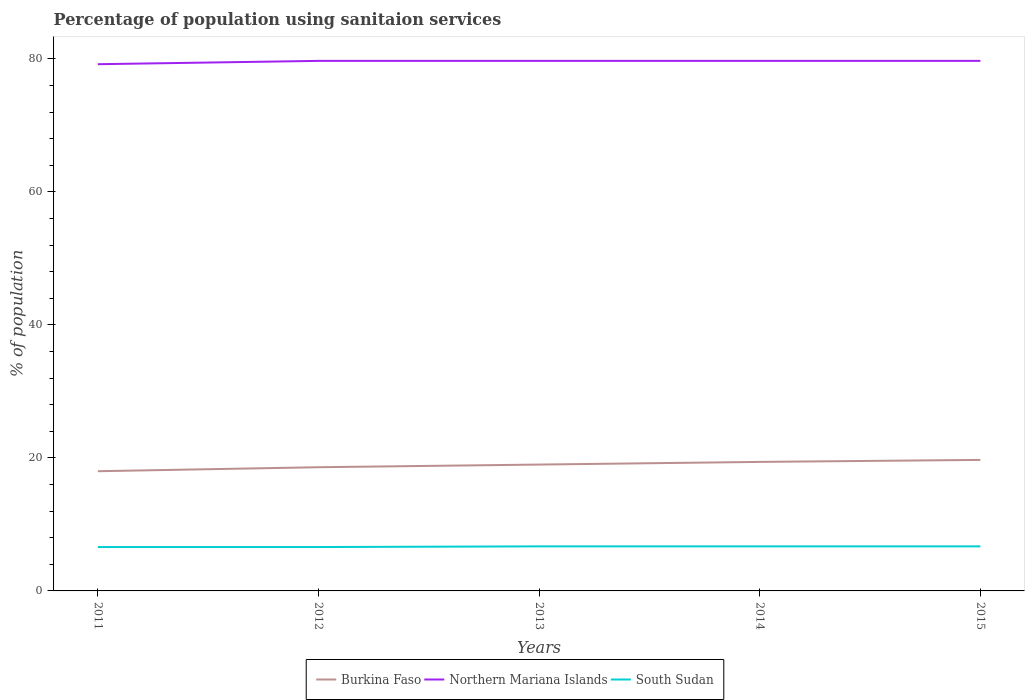Is the number of lines equal to the number of legend labels?
Ensure brevity in your answer.  Yes. What is the total percentage of population using sanitaion services in Burkina Faso in the graph?
Provide a short and direct response. -1.4. What is the difference between the highest and the second highest percentage of population using sanitaion services in Northern Mariana Islands?
Keep it short and to the point. 0.5. Is the percentage of population using sanitaion services in Burkina Faso strictly greater than the percentage of population using sanitaion services in Northern Mariana Islands over the years?
Make the answer very short. Yes. How many years are there in the graph?
Keep it short and to the point. 5. Are the values on the major ticks of Y-axis written in scientific E-notation?
Provide a short and direct response. No. Where does the legend appear in the graph?
Your answer should be very brief. Bottom center. How many legend labels are there?
Make the answer very short. 3. How are the legend labels stacked?
Offer a very short reply. Horizontal. What is the title of the graph?
Your response must be concise. Percentage of population using sanitaion services. What is the label or title of the X-axis?
Offer a very short reply. Years. What is the label or title of the Y-axis?
Provide a short and direct response. % of population. What is the % of population of Northern Mariana Islands in 2011?
Your answer should be very brief. 79.2. What is the % of population in Burkina Faso in 2012?
Give a very brief answer. 18.6. What is the % of population in Northern Mariana Islands in 2012?
Provide a short and direct response. 79.7. What is the % of population in Northern Mariana Islands in 2013?
Offer a very short reply. 79.7. What is the % of population in South Sudan in 2013?
Provide a short and direct response. 6.7. What is the % of population in Burkina Faso in 2014?
Provide a succinct answer. 19.4. What is the % of population of Northern Mariana Islands in 2014?
Your answer should be compact. 79.7. What is the % of population in Northern Mariana Islands in 2015?
Offer a terse response. 79.7. Across all years, what is the maximum % of population of Northern Mariana Islands?
Your answer should be very brief. 79.7. Across all years, what is the minimum % of population of Burkina Faso?
Keep it short and to the point. 18. Across all years, what is the minimum % of population in Northern Mariana Islands?
Ensure brevity in your answer.  79.2. What is the total % of population in Burkina Faso in the graph?
Provide a succinct answer. 94.7. What is the total % of population in Northern Mariana Islands in the graph?
Offer a terse response. 398. What is the total % of population in South Sudan in the graph?
Provide a short and direct response. 33.3. What is the difference between the % of population of Burkina Faso in 2011 and that in 2012?
Offer a terse response. -0.6. What is the difference between the % of population of South Sudan in 2011 and that in 2013?
Provide a succinct answer. -0.1. What is the difference between the % of population of Burkina Faso in 2011 and that in 2014?
Keep it short and to the point. -1.4. What is the difference between the % of population in Northern Mariana Islands in 2011 and that in 2015?
Provide a short and direct response. -0.5. What is the difference between the % of population of South Sudan in 2012 and that in 2013?
Provide a succinct answer. -0.1. What is the difference between the % of population in Burkina Faso in 2012 and that in 2015?
Your response must be concise. -1.1. What is the difference between the % of population in Northern Mariana Islands in 2012 and that in 2015?
Offer a terse response. 0. What is the difference between the % of population in South Sudan in 2012 and that in 2015?
Keep it short and to the point. -0.1. What is the difference between the % of population of South Sudan in 2013 and that in 2014?
Provide a succinct answer. 0. What is the difference between the % of population of Burkina Faso in 2013 and that in 2015?
Give a very brief answer. -0.7. What is the difference between the % of population in Northern Mariana Islands in 2013 and that in 2015?
Provide a short and direct response. 0. What is the difference between the % of population of South Sudan in 2014 and that in 2015?
Your answer should be compact. 0. What is the difference between the % of population in Burkina Faso in 2011 and the % of population in Northern Mariana Islands in 2012?
Your answer should be compact. -61.7. What is the difference between the % of population of Northern Mariana Islands in 2011 and the % of population of South Sudan in 2012?
Provide a succinct answer. 72.6. What is the difference between the % of population in Burkina Faso in 2011 and the % of population in Northern Mariana Islands in 2013?
Provide a short and direct response. -61.7. What is the difference between the % of population of Burkina Faso in 2011 and the % of population of South Sudan in 2013?
Offer a terse response. 11.3. What is the difference between the % of population of Northern Mariana Islands in 2011 and the % of population of South Sudan in 2013?
Keep it short and to the point. 72.5. What is the difference between the % of population in Burkina Faso in 2011 and the % of population in Northern Mariana Islands in 2014?
Offer a very short reply. -61.7. What is the difference between the % of population of Burkina Faso in 2011 and the % of population of South Sudan in 2014?
Offer a terse response. 11.3. What is the difference between the % of population in Northern Mariana Islands in 2011 and the % of population in South Sudan in 2014?
Make the answer very short. 72.5. What is the difference between the % of population of Burkina Faso in 2011 and the % of population of Northern Mariana Islands in 2015?
Provide a short and direct response. -61.7. What is the difference between the % of population of Burkina Faso in 2011 and the % of population of South Sudan in 2015?
Your answer should be very brief. 11.3. What is the difference between the % of population of Northern Mariana Islands in 2011 and the % of population of South Sudan in 2015?
Your response must be concise. 72.5. What is the difference between the % of population of Burkina Faso in 2012 and the % of population of Northern Mariana Islands in 2013?
Give a very brief answer. -61.1. What is the difference between the % of population of Burkina Faso in 2012 and the % of population of Northern Mariana Islands in 2014?
Offer a terse response. -61.1. What is the difference between the % of population in Northern Mariana Islands in 2012 and the % of population in South Sudan in 2014?
Offer a terse response. 73. What is the difference between the % of population of Burkina Faso in 2012 and the % of population of Northern Mariana Islands in 2015?
Offer a very short reply. -61.1. What is the difference between the % of population of Burkina Faso in 2012 and the % of population of South Sudan in 2015?
Make the answer very short. 11.9. What is the difference between the % of population in Burkina Faso in 2013 and the % of population in Northern Mariana Islands in 2014?
Your answer should be compact. -60.7. What is the difference between the % of population of Burkina Faso in 2013 and the % of population of South Sudan in 2014?
Keep it short and to the point. 12.3. What is the difference between the % of population of Burkina Faso in 2013 and the % of population of Northern Mariana Islands in 2015?
Give a very brief answer. -60.7. What is the difference between the % of population in Burkina Faso in 2013 and the % of population in South Sudan in 2015?
Make the answer very short. 12.3. What is the difference between the % of population of Northern Mariana Islands in 2013 and the % of population of South Sudan in 2015?
Offer a terse response. 73. What is the difference between the % of population of Burkina Faso in 2014 and the % of population of Northern Mariana Islands in 2015?
Offer a terse response. -60.3. What is the average % of population of Burkina Faso per year?
Give a very brief answer. 18.94. What is the average % of population in Northern Mariana Islands per year?
Your answer should be compact. 79.6. What is the average % of population of South Sudan per year?
Your answer should be compact. 6.66. In the year 2011, what is the difference between the % of population in Burkina Faso and % of population in Northern Mariana Islands?
Provide a short and direct response. -61.2. In the year 2011, what is the difference between the % of population of Burkina Faso and % of population of South Sudan?
Make the answer very short. 11.4. In the year 2011, what is the difference between the % of population in Northern Mariana Islands and % of population in South Sudan?
Your answer should be compact. 72.6. In the year 2012, what is the difference between the % of population of Burkina Faso and % of population of Northern Mariana Islands?
Give a very brief answer. -61.1. In the year 2012, what is the difference between the % of population of Northern Mariana Islands and % of population of South Sudan?
Offer a terse response. 73.1. In the year 2013, what is the difference between the % of population in Burkina Faso and % of population in Northern Mariana Islands?
Offer a terse response. -60.7. In the year 2014, what is the difference between the % of population of Burkina Faso and % of population of Northern Mariana Islands?
Keep it short and to the point. -60.3. In the year 2014, what is the difference between the % of population in Burkina Faso and % of population in South Sudan?
Offer a very short reply. 12.7. In the year 2014, what is the difference between the % of population in Northern Mariana Islands and % of population in South Sudan?
Offer a terse response. 73. In the year 2015, what is the difference between the % of population of Burkina Faso and % of population of Northern Mariana Islands?
Give a very brief answer. -60. In the year 2015, what is the difference between the % of population of Northern Mariana Islands and % of population of South Sudan?
Your answer should be very brief. 73. What is the ratio of the % of population in Burkina Faso in 2011 to that in 2012?
Your answer should be compact. 0.97. What is the ratio of the % of population of South Sudan in 2011 to that in 2012?
Keep it short and to the point. 1. What is the ratio of the % of population in Burkina Faso in 2011 to that in 2013?
Your response must be concise. 0.95. What is the ratio of the % of population in Northern Mariana Islands in 2011 to that in 2013?
Provide a succinct answer. 0.99. What is the ratio of the % of population of South Sudan in 2011 to that in 2013?
Provide a short and direct response. 0.99. What is the ratio of the % of population in Burkina Faso in 2011 to that in 2014?
Your answer should be compact. 0.93. What is the ratio of the % of population in Northern Mariana Islands in 2011 to that in 2014?
Ensure brevity in your answer.  0.99. What is the ratio of the % of population in South Sudan in 2011 to that in 2014?
Your answer should be compact. 0.99. What is the ratio of the % of population in Burkina Faso in 2011 to that in 2015?
Provide a succinct answer. 0.91. What is the ratio of the % of population in Northern Mariana Islands in 2011 to that in 2015?
Your answer should be very brief. 0.99. What is the ratio of the % of population in South Sudan in 2011 to that in 2015?
Provide a short and direct response. 0.99. What is the ratio of the % of population of Burkina Faso in 2012 to that in 2013?
Give a very brief answer. 0.98. What is the ratio of the % of population of South Sudan in 2012 to that in 2013?
Your answer should be very brief. 0.99. What is the ratio of the % of population of Burkina Faso in 2012 to that in 2014?
Offer a terse response. 0.96. What is the ratio of the % of population of South Sudan in 2012 to that in 2014?
Your answer should be very brief. 0.99. What is the ratio of the % of population of Burkina Faso in 2012 to that in 2015?
Offer a terse response. 0.94. What is the ratio of the % of population in South Sudan in 2012 to that in 2015?
Offer a very short reply. 0.99. What is the ratio of the % of population in Burkina Faso in 2013 to that in 2014?
Your answer should be compact. 0.98. What is the ratio of the % of population in Burkina Faso in 2013 to that in 2015?
Offer a very short reply. 0.96. What is the ratio of the % of population in South Sudan in 2013 to that in 2015?
Provide a succinct answer. 1. What is the ratio of the % of population in Burkina Faso in 2014 to that in 2015?
Ensure brevity in your answer.  0.98. What is the difference between the highest and the second highest % of population of Northern Mariana Islands?
Offer a terse response. 0. What is the difference between the highest and the second highest % of population of South Sudan?
Make the answer very short. 0. What is the difference between the highest and the lowest % of population in Burkina Faso?
Your answer should be very brief. 1.7. What is the difference between the highest and the lowest % of population of Northern Mariana Islands?
Make the answer very short. 0.5. 